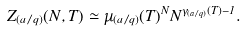Convert formula to latex. <formula><loc_0><loc_0><loc_500><loc_500>Z _ { ( a / q ) } ( N , T ) \simeq \mu _ { ( a / q ) } ( T ) ^ { N } N ^ { \gamma _ { ( a / q ) } ( T ) - 1 } .</formula> 